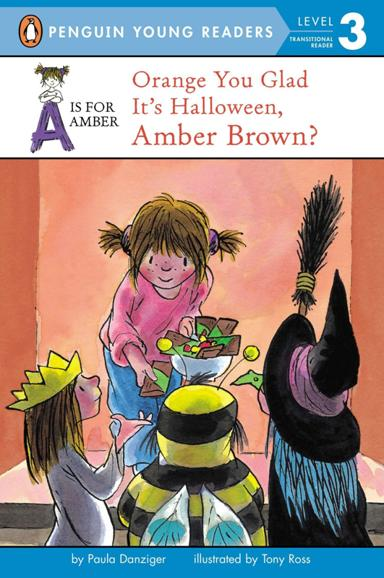Who is the author and illustrator of the book? The creative minds behind this delightful book are author Paula Danziger and illustrator Tony Ross. Their collaboration brings to life the whimsical world of Amber Brown with vibrant illustrations and captivating storytelling. 